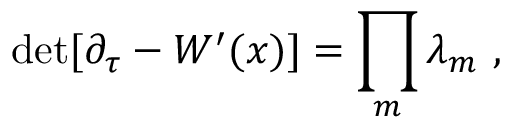Convert formula to latex. <formula><loc_0><loc_0><loc_500><loc_500>{ d e t } [ \partial _ { \tau } - W ^ { \prime } ( x ) ] = \prod _ { m } \lambda _ { m } ,</formula> 